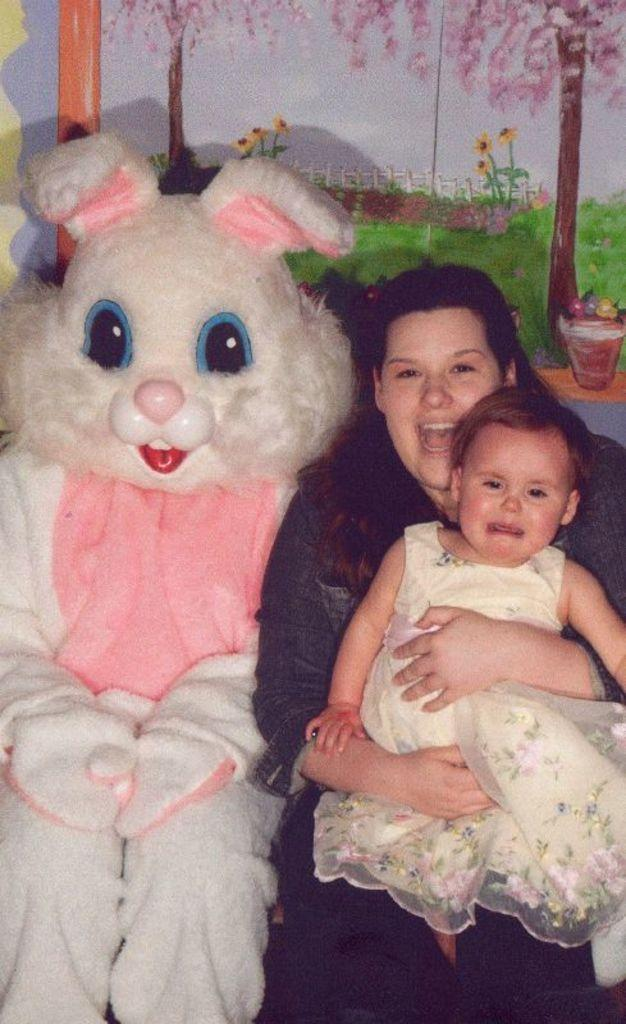Who are the people present in the image? There is a girl and a woman in the image. What other character can be seen in the image? There is a mascot in the image. What can be seen on the wall in the background of the image? There is a painting on the wall in the background of the image. What is the beggar's opinion about the surprise in the image? There is no beggar present in the image, and therefore, no opinion or surprise can be attributed to them. 